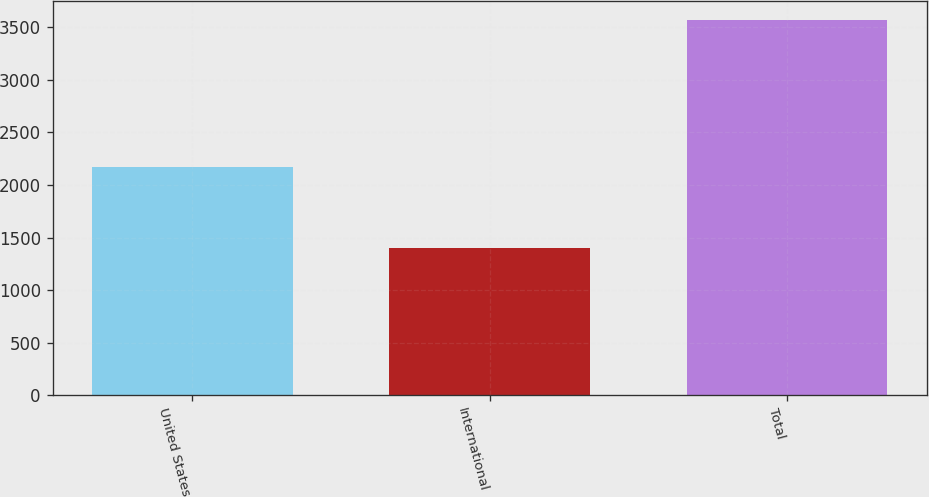Convert chart. <chart><loc_0><loc_0><loc_500><loc_500><bar_chart><fcel>United States<fcel>International<fcel>Total<nl><fcel>2175<fcel>1397<fcel>3572<nl></chart> 